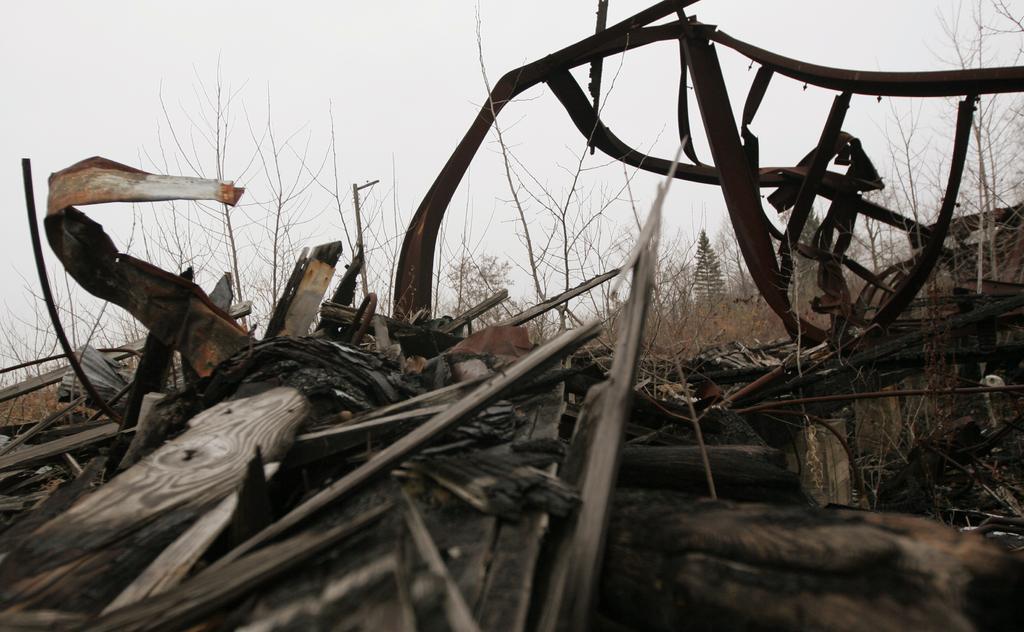Could you give a brief overview of what you see in this image? In this image we can see some plants, grass, wooden sticks, iron rods, also we can see the sky. 